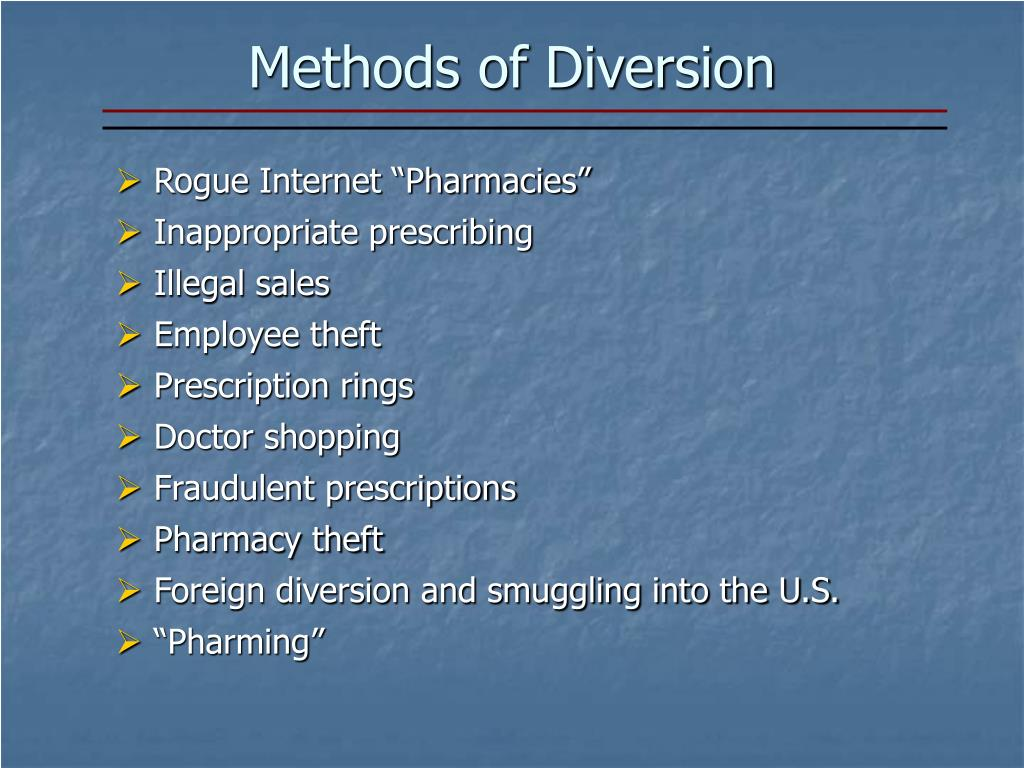How do 'Prescription rings' typically operate? Prescription rings often involve a group of individuals working together to illegally obtain and distribute prescription medications. The operation usually involves a combination of corrupt healthcare providers, patients, and distributors. Healthcare providers may write prescriptions for non-existent patients or exaggerate medical conditions. These fraudulent prescriptions are then filled at pharmacies, with or without the complicity of pharmacy staff. Once the drugs are obtained, they are sold on the black market, often through a network of dealers. These rings can be highly organized, using sophisticated methods to evade detection, such as recruiting multiple doctors and pharmacies to avoid raising suspicions. The profits from these illegal sales are substantial, fueling further criminal activities. 